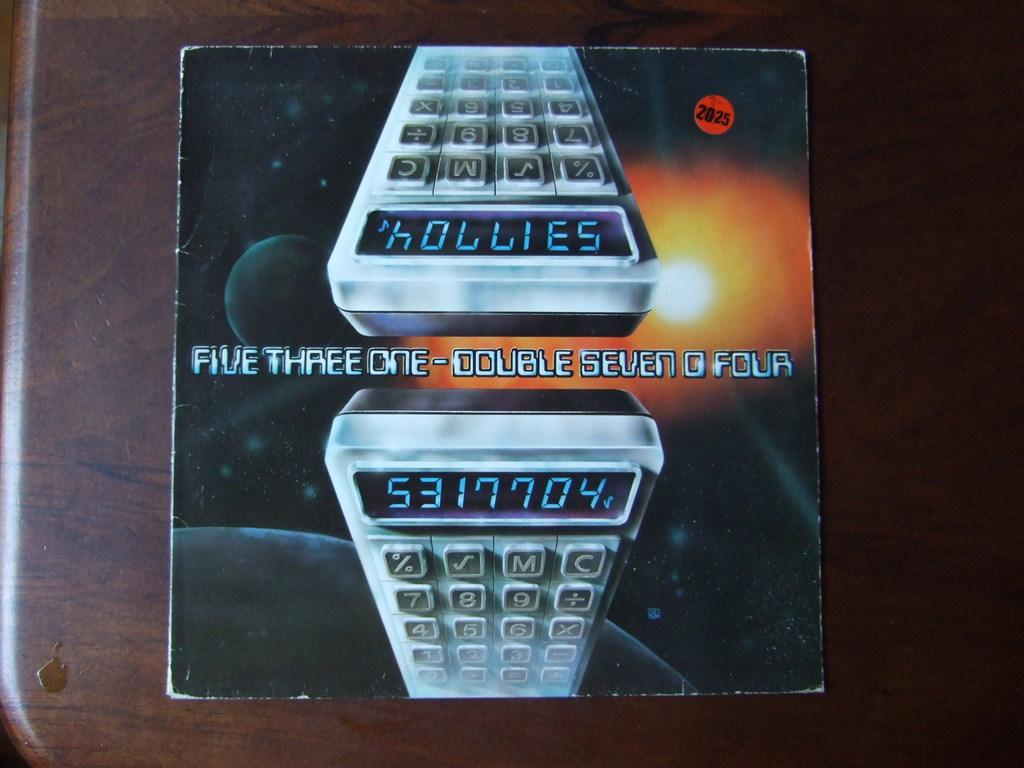<image>
Describe the image concisely. wooden table with what looks like an album on it that has picture of 2 calculators and words five three one-double seven four 